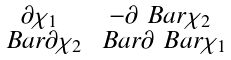<formula> <loc_0><loc_0><loc_500><loc_500>\begin{smallmatrix} \partial \chi _ { 1 } & - \partial \ B a r { \chi } _ { 2 } \\ \ B a r { \partial } \chi _ { 2 } & \ B a r { \partial } \ B a r { \chi } _ { 1 } \end{smallmatrix}</formula> 